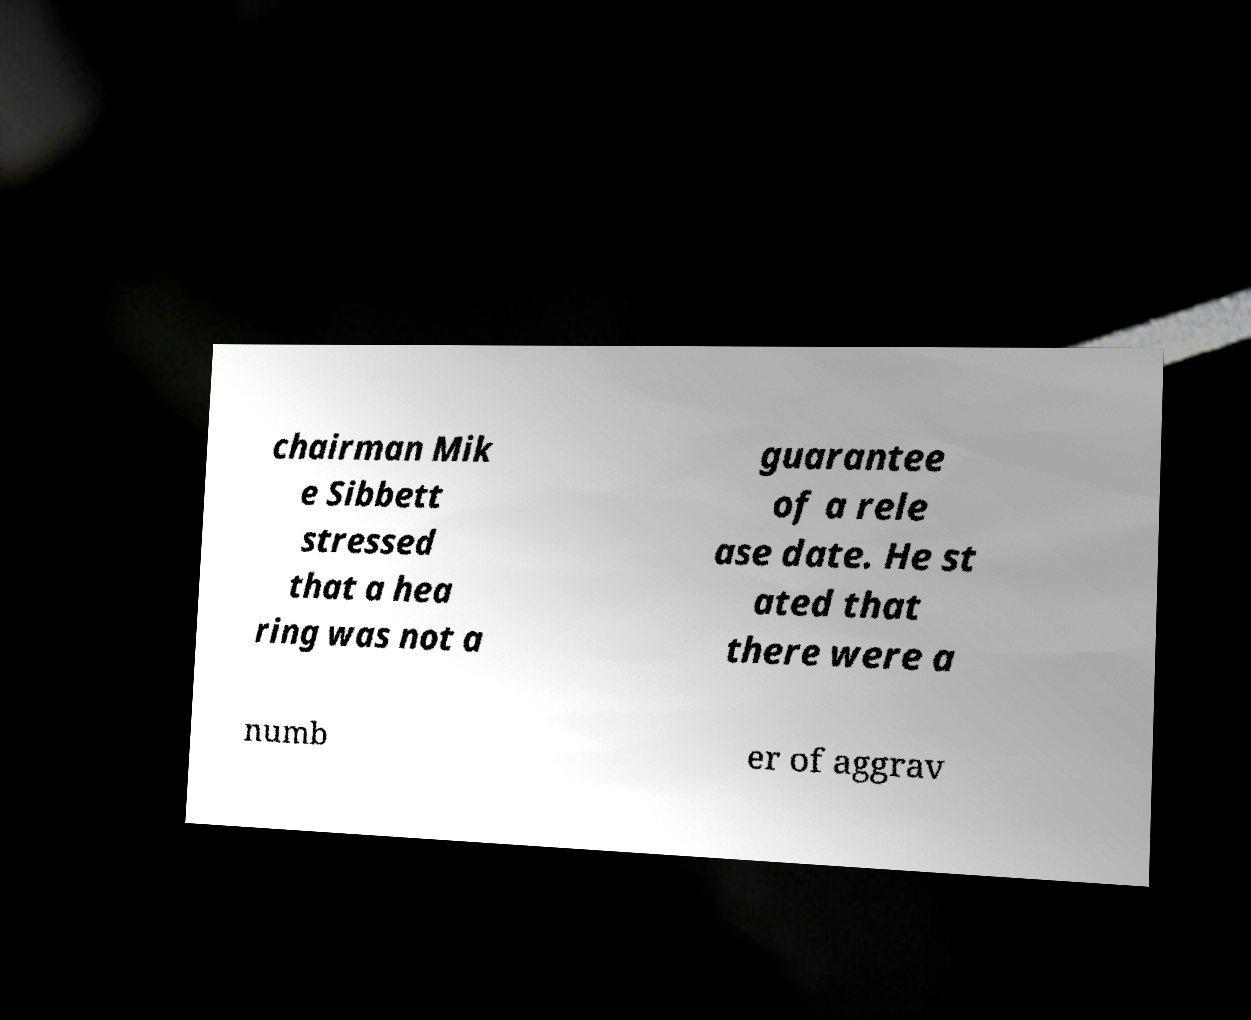What messages or text are displayed in this image? I need them in a readable, typed format. chairman Mik e Sibbett stressed that a hea ring was not a guarantee of a rele ase date. He st ated that there were a numb er of aggrav 